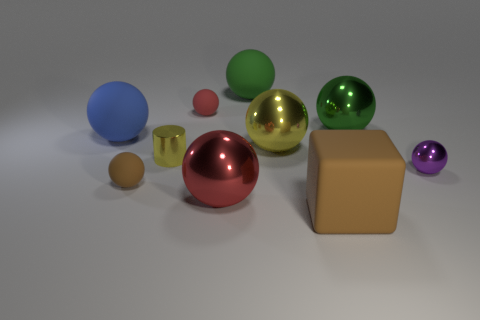Subtract all yellow shiny spheres. How many spheres are left? 7 Subtract all purple cylinders. How many red balls are left? 2 Subtract all green balls. How many balls are left? 6 Subtract all cylinders. How many objects are left? 9 Subtract all tiny shiny things. Subtract all rubber objects. How many objects are left? 3 Add 1 tiny red things. How many tiny red things are left? 2 Add 1 large blue rubber cubes. How many large blue rubber cubes exist? 1 Subtract 1 blue spheres. How many objects are left? 9 Subtract 2 spheres. How many spheres are left? 6 Subtract all blue blocks. Subtract all gray spheres. How many blocks are left? 1 